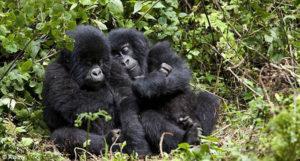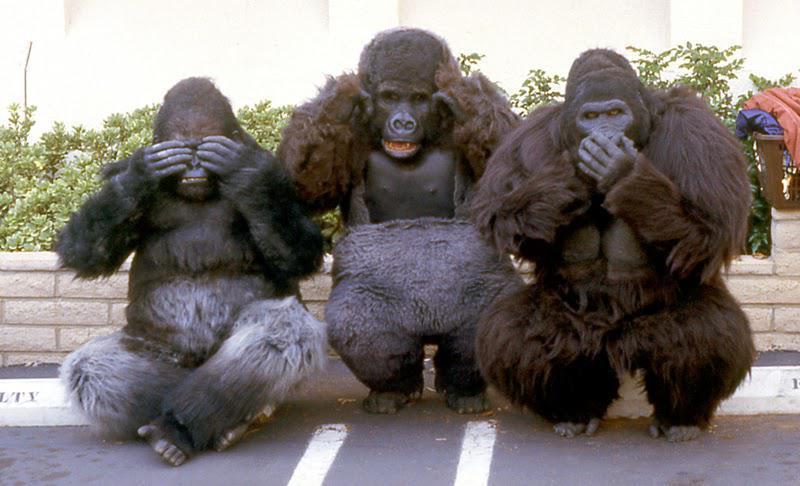The first image is the image on the left, the second image is the image on the right. Evaluate the accuracy of this statement regarding the images: "At least one of the gorillas has an open mouth.". Is it true? Answer yes or no. Yes. The first image is the image on the left, the second image is the image on the right. Assess this claim about the two images: "A total of four gorillas are shown, and left and right images do not contain the same number of gorillas.". Correct or not? Answer yes or no. No. 